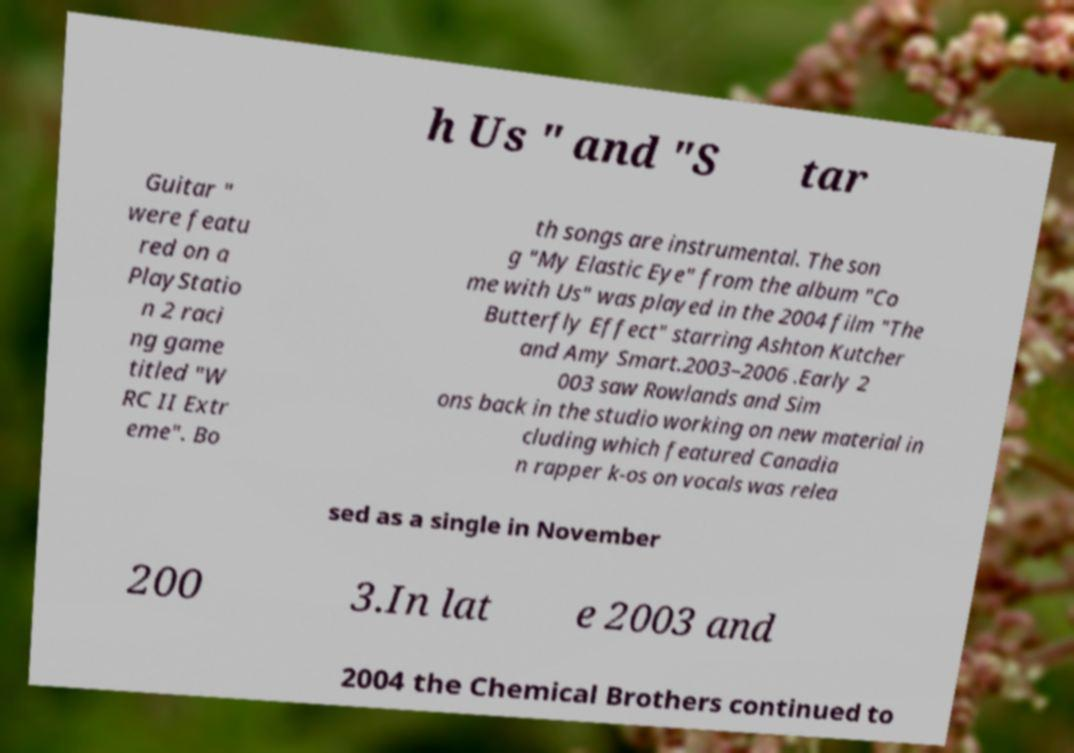There's text embedded in this image that I need extracted. Can you transcribe it verbatim? h Us " and "S tar Guitar " were featu red on a PlayStatio n 2 raci ng game titled "W RC II Extr eme". Bo th songs are instrumental. The son g "My Elastic Eye" from the album "Co me with Us" was played in the 2004 film "The Butterfly Effect" starring Ashton Kutcher and Amy Smart.2003–2006 .Early 2 003 saw Rowlands and Sim ons back in the studio working on new material in cluding which featured Canadia n rapper k-os on vocals was relea sed as a single in November 200 3.In lat e 2003 and 2004 the Chemical Brothers continued to 